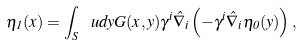<formula> <loc_0><loc_0><loc_500><loc_500>\eta _ { 1 } ( x ) = \int _ { S } \, \ u d { y } G ( x , y ) \gamma ^ { i } \hat { \nabla } _ { i } \left ( - \gamma ^ { i } \hat { \nabla } _ { i } \eta _ { 0 } ( y ) \right ) ,</formula> 